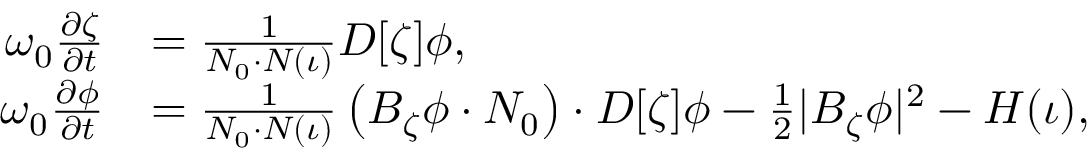<formula> <loc_0><loc_0><loc_500><loc_500>\begin{array} { r l } { \omega _ { 0 } \frac { \partial \zeta } { \partial t } } & { = \frac { 1 } { N _ { 0 } \cdot N ( \iota ) } D [ \zeta ] \phi , } \\ { \omega _ { 0 } \frac { \partial \phi } { \partial t } } & { = \frac { 1 } { N _ { 0 } \cdot N ( \iota ) } \left ( B _ { \zeta } \phi \cdot N _ { 0 } \right ) \cdot D [ \zeta ] \phi - \frac { 1 } { 2 } | B _ { \zeta } \phi | ^ { 2 } - H ( \iota ) , } \end{array}</formula> 